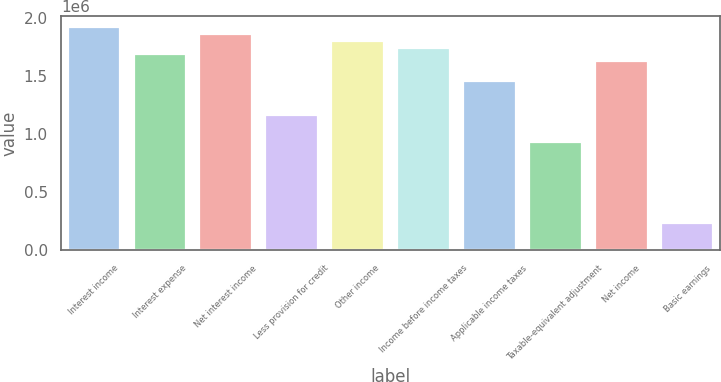Convert chart. <chart><loc_0><loc_0><loc_500><loc_500><bar_chart><fcel>Interest income<fcel>Interest expense<fcel>Net interest income<fcel>Less provision for credit<fcel>Other income<fcel>Income before income taxes<fcel>Applicable income taxes<fcel>Taxable-equivalent adjustment<fcel>Net income<fcel>Basic earnings<nl><fcel>1.91632e+06<fcel>1.68404e+06<fcel>1.85825e+06<fcel>1.16141e+06<fcel>1.80018e+06<fcel>1.74211e+06<fcel>1.45176e+06<fcel>929126<fcel>1.62597e+06<fcel>232282<nl></chart> 